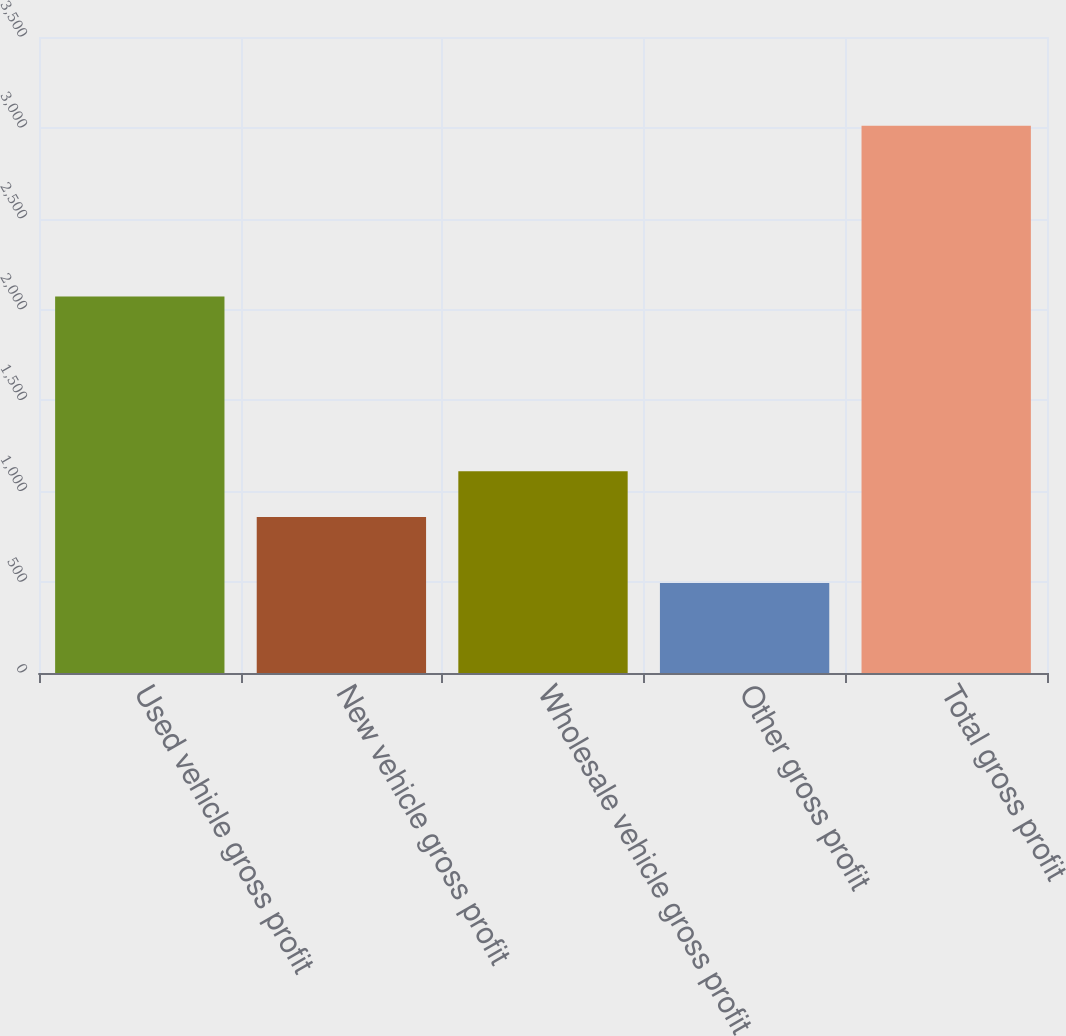<chart> <loc_0><loc_0><loc_500><loc_500><bar_chart><fcel>Used vehicle gross profit<fcel>New vehicle gross profit<fcel>Wholesale vehicle gross profit<fcel>Other gross profit<fcel>Total gross profit<nl><fcel>2072<fcel>858<fcel>1109.6<fcel>495<fcel>3011<nl></chart> 